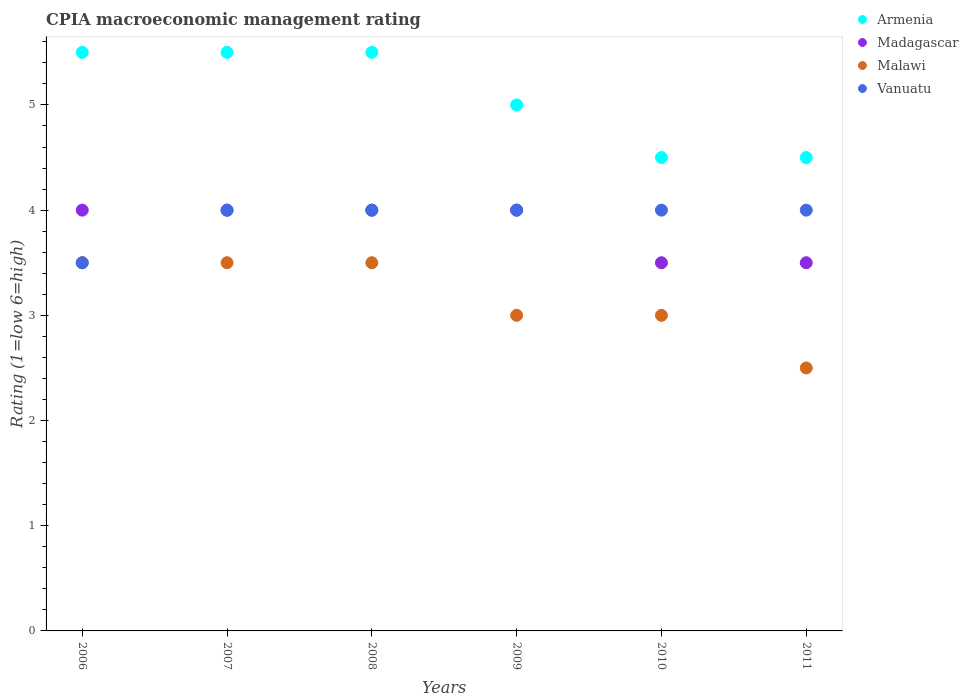How many different coloured dotlines are there?
Ensure brevity in your answer.  4. Is the number of dotlines equal to the number of legend labels?
Offer a very short reply. Yes. What is the CPIA rating in Madagascar in 2009?
Give a very brief answer. 4. Across all years, what is the minimum CPIA rating in Malawi?
Your answer should be very brief. 2.5. In which year was the CPIA rating in Malawi maximum?
Give a very brief answer. 2006. What is the total CPIA rating in Armenia in the graph?
Your answer should be compact. 30.5. What is the average CPIA rating in Madagascar per year?
Your answer should be compact. 3.83. In the year 2010, what is the difference between the CPIA rating in Vanuatu and CPIA rating in Madagascar?
Offer a terse response. 0.5. Is the CPIA rating in Madagascar in 2006 less than that in 2009?
Ensure brevity in your answer.  No. What is the difference between the highest and the second highest CPIA rating in Madagascar?
Give a very brief answer. 0. What is the difference between the highest and the lowest CPIA rating in Vanuatu?
Offer a terse response. 0.5. In how many years, is the CPIA rating in Malawi greater than the average CPIA rating in Malawi taken over all years?
Provide a short and direct response. 3. Is it the case that in every year, the sum of the CPIA rating in Madagascar and CPIA rating in Armenia  is greater than the sum of CPIA rating in Malawi and CPIA rating in Vanuatu?
Make the answer very short. No. Is it the case that in every year, the sum of the CPIA rating in Vanuatu and CPIA rating in Madagascar  is greater than the CPIA rating in Malawi?
Ensure brevity in your answer.  Yes. Does the CPIA rating in Malawi monotonically increase over the years?
Offer a very short reply. No. How many dotlines are there?
Offer a terse response. 4. What is the difference between two consecutive major ticks on the Y-axis?
Offer a very short reply. 1. Does the graph contain any zero values?
Your answer should be compact. No. Does the graph contain grids?
Offer a terse response. No. What is the title of the graph?
Provide a short and direct response. CPIA macroeconomic management rating. What is the label or title of the X-axis?
Ensure brevity in your answer.  Years. What is the label or title of the Y-axis?
Provide a succinct answer. Rating (1=low 6=high). What is the Rating (1=low 6=high) in Armenia in 2006?
Offer a very short reply. 5.5. What is the Rating (1=low 6=high) of Vanuatu in 2006?
Offer a very short reply. 3.5. What is the Rating (1=low 6=high) in Malawi in 2007?
Offer a very short reply. 3.5. What is the Rating (1=low 6=high) of Armenia in 2008?
Your answer should be very brief. 5.5. What is the Rating (1=low 6=high) in Madagascar in 2008?
Your answer should be very brief. 4. What is the Rating (1=low 6=high) in Malawi in 2008?
Make the answer very short. 3.5. What is the Rating (1=low 6=high) in Armenia in 2009?
Offer a terse response. 5. What is the Rating (1=low 6=high) of Malawi in 2009?
Provide a short and direct response. 3. What is the Rating (1=low 6=high) of Vanuatu in 2009?
Your answer should be very brief. 4. What is the Rating (1=low 6=high) of Armenia in 2010?
Give a very brief answer. 4.5. What is the Rating (1=low 6=high) in Madagascar in 2010?
Keep it short and to the point. 3.5. What is the Rating (1=low 6=high) of Vanuatu in 2010?
Give a very brief answer. 4. What is the Rating (1=low 6=high) of Madagascar in 2011?
Your answer should be very brief. 3.5. Across all years, what is the maximum Rating (1=low 6=high) of Vanuatu?
Provide a short and direct response. 4. Across all years, what is the minimum Rating (1=low 6=high) of Malawi?
Keep it short and to the point. 2.5. Across all years, what is the minimum Rating (1=low 6=high) in Vanuatu?
Your answer should be compact. 3.5. What is the total Rating (1=low 6=high) in Armenia in the graph?
Provide a succinct answer. 30.5. What is the total Rating (1=low 6=high) of Madagascar in the graph?
Your response must be concise. 23. What is the total Rating (1=low 6=high) in Malawi in the graph?
Provide a short and direct response. 19. What is the difference between the Rating (1=low 6=high) in Madagascar in 2006 and that in 2007?
Keep it short and to the point. 0. What is the difference between the Rating (1=low 6=high) of Malawi in 2006 and that in 2007?
Offer a terse response. 0. What is the difference between the Rating (1=low 6=high) of Vanuatu in 2006 and that in 2007?
Your answer should be very brief. -0.5. What is the difference between the Rating (1=low 6=high) in Madagascar in 2006 and that in 2008?
Keep it short and to the point. 0. What is the difference between the Rating (1=low 6=high) of Malawi in 2006 and that in 2008?
Make the answer very short. 0. What is the difference between the Rating (1=low 6=high) in Vanuatu in 2006 and that in 2008?
Offer a terse response. -0.5. What is the difference between the Rating (1=low 6=high) of Armenia in 2006 and that in 2010?
Provide a succinct answer. 1. What is the difference between the Rating (1=low 6=high) in Madagascar in 2006 and that in 2010?
Your answer should be very brief. 0.5. What is the difference between the Rating (1=low 6=high) in Malawi in 2006 and that in 2010?
Your answer should be very brief. 0.5. What is the difference between the Rating (1=low 6=high) in Malawi in 2006 and that in 2011?
Make the answer very short. 1. What is the difference between the Rating (1=low 6=high) of Vanuatu in 2007 and that in 2008?
Your response must be concise. 0. What is the difference between the Rating (1=low 6=high) in Armenia in 2007 and that in 2009?
Offer a terse response. 0.5. What is the difference between the Rating (1=low 6=high) of Madagascar in 2007 and that in 2009?
Offer a very short reply. 0. What is the difference between the Rating (1=low 6=high) in Malawi in 2007 and that in 2009?
Keep it short and to the point. 0.5. What is the difference between the Rating (1=low 6=high) in Vanuatu in 2007 and that in 2009?
Your answer should be very brief. 0. What is the difference between the Rating (1=low 6=high) in Malawi in 2007 and that in 2010?
Offer a terse response. 0.5. What is the difference between the Rating (1=low 6=high) of Armenia in 2007 and that in 2011?
Your answer should be compact. 1. What is the difference between the Rating (1=low 6=high) in Malawi in 2007 and that in 2011?
Your answer should be very brief. 1. What is the difference between the Rating (1=low 6=high) of Armenia in 2008 and that in 2009?
Provide a succinct answer. 0.5. What is the difference between the Rating (1=low 6=high) of Malawi in 2008 and that in 2009?
Your answer should be compact. 0.5. What is the difference between the Rating (1=low 6=high) of Armenia in 2008 and that in 2010?
Make the answer very short. 1. What is the difference between the Rating (1=low 6=high) of Madagascar in 2008 and that in 2010?
Give a very brief answer. 0.5. What is the difference between the Rating (1=low 6=high) in Malawi in 2008 and that in 2010?
Offer a terse response. 0.5. What is the difference between the Rating (1=low 6=high) of Armenia in 2008 and that in 2011?
Provide a short and direct response. 1. What is the difference between the Rating (1=low 6=high) of Armenia in 2009 and that in 2010?
Provide a succinct answer. 0.5. What is the difference between the Rating (1=low 6=high) in Vanuatu in 2009 and that in 2010?
Provide a succinct answer. 0. What is the difference between the Rating (1=low 6=high) of Vanuatu in 2009 and that in 2011?
Your response must be concise. 0. What is the difference between the Rating (1=low 6=high) of Armenia in 2010 and that in 2011?
Keep it short and to the point. 0. What is the difference between the Rating (1=low 6=high) in Vanuatu in 2010 and that in 2011?
Your answer should be compact. 0. What is the difference between the Rating (1=low 6=high) of Armenia in 2006 and the Rating (1=low 6=high) of Madagascar in 2007?
Offer a terse response. 1.5. What is the difference between the Rating (1=low 6=high) in Armenia in 2006 and the Rating (1=low 6=high) in Malawi in 2007?
Provide a short and direct response. 2. What is the difference between the Rating (1=low 6=high) of Armenia in 2006 and the Rating (1=low 6=high) of Vanuatu in 2007?
Offer a terse response. 1.5. What is the difference between the Rating (1=low 6=high) of Madagascar in 2006 and the Rating (1=low 6=high) of Malawi in 2007?
Your response must be concise. 0.5. What is the difference between the Rating (1=low 6=high) in Armenia in 2006 and the Rating (1=low 6=high) in Malawi in 2009?
Offer a very short reply. 2.5. What is the difference between the Rating (1=low 6=high) in Malawi in 2006 and the Rating (1=low 6=high) in Vanuatu in 2009?
Your response must be concise. -0.5. What is the difference between the Rating (1=low 6=high) of Armenia in 2006 and the Rating (1=low 6=high) of Malawi in 2010?
Offer a very short reply. 2.5. What is the difference between the Rating (1=low 6=high) in Madagascar in 2006 and the Rating (1=low 6=high) in Malawi in 2010?
Your response must be concise. 1. What is the difference between the Rating (1=low 6=high) in Madagascar in 2006 and the Rating (1=low 6=high) in Vanuatu in 2010?
Make the answer very short. 0. What is the difference between the Rating (1=low 6=high) of Armenia in 2006 and the Rating (1=low 6=high) of Vanuatu in 2011?
Make the answer very short. 1.5. What is the difference between the Rating (1=low 6=high) of Madagascar in 2006 and the Rating (1=low 6=high) of Malawi in 2011?
Ensure brevity in your answer.  1.5. What is the difference between the Rating (1=low 6=high) of Madagascar in 2006 and the Rating (1=low 6=high) of Vanuatu in 2011?
Your answer should be compact. 0. What is the difference between the Rating (1=low 6=high) in Malawi in 2006 and the Rating (1=low 6=high) in Vanuatu in 2011?
Your response must be concise. -0.5. What is the difference between the Rating (1=low 6=high) of Armenia in 2007 and the Rating (1=low 6=high) of Vanuatu in 2008?
Make the answer very short. 1.5. What is the difference between the Rating (1=low 6=high) in Madagascar in 2007 and the Rating (1=low 6=high) in Malawi in 2008?
Provide a short and direct response. 0.5. What is the difference between the Rating (1=low 6=high) of Armenia in 2007 and the Rating (1=low 6=high) of Malawi in 2009?
Give a very brief answer. 2.5. What is the difference between the Rating (1=low 6=high) of Madagascar in 2007 and the Rating (1=low 6=high) of Malawi in 2009?
Keep it short and to the point. 1. What is the difference between the Rating (1=low 6=high) in Armenia in 2007 and the Rating (1=low 6=high) in Madagascar in 2010?
Make the answer very short. 2. What is the difference between the Rating (1=low 6=high) in Madagascar in 2007 and the Rating (1=low 6=high) in Vanuatu in 2010?
Make the answer very short. 0. What is the difference between the Rating (1=low 6=high) in Armenia in 2008 and the Rating (1=low 6=high) in Madagascar in 2009?
Offer a very short reply. 1.5. What is the difference between the Rating (1=low 6=high) in Armenia in 2008 and the Rating (1=low 6=high) in Vanuatu in 2009?
Your answer should be compact. 1.5. What is the difference between the Rating (1=low 6=high) of Madagascar in 2008 and the Rating (1=low 6=high) of Vanuatu in 2009?
Your response must be concise. 0. What is the difference between the Rating (1=low 6=high) of Armenia in 2008 and the Rating (1=low 6=high) of Madagascar in 2010?
Provide a short and direct response. 2. What is the difference between the Rating (1=low 6=high) in Armenia in 2008 and the Rating (1=low 6=high) in Malawi in 2010?
Your answer should be very brief. 2.5. What is the difference between the Rating (1=low 6=high) in Armenia in 2008 and the Rating (1=low 6=high) in Vanuatu in 2010?
Your response must be concise. 1.5. What is the difference between the Rating (1=low 6=high) of Madagascar in 2008 and the Rating (1=low 6=high) of Malawi in 2010?
Ensure brevity in your answer.  1. What is the difference between the Rating (1=low 6=high) of Madagascar in 2008 and the Rating (1=low 6=high) of Vanuatu in 2010?
Provide a short and direct response. 0. What is the difference between the Rating (1=low 6=high) in Armenia in 2008 and the Rating (1=low 6=high) in Madagascar in 2011?
Provide a succinct answer. 2. What is the difference between the Rating (1=low 6=high) of Armenia in 2008 and the Rating (1=low 6=high) of Malawi in 2011?
Give a very brief answer. 3. What is the difference between the Rating (1=low 6=high) in Madagascar in 2008 and the Rating (1=low 6=high) in Malawi in 2011?
Your answer should be compact. 1.5. What is the difference between the Rating (1=low 6=high) in Madagascar in 2008 and the Rating (1=low 6=high) in Vanuatu in 2011?
Make the answer very short. 0. What is the difference between the Rating (1=low 6=high) in Malawi in 2008 and the Rating (1=low 6=high) in Vanuatu in 2011?
Your response must be concise. -0.5. What is the difference between the Rating (1=low 6=high) of Armenia in 2009 and the Rating (1=low 6=high) of Madagascar in 2010?
Keep it short and to the point. 1.5. What is the difference between the Rating (1=low 6=high) of Armenia in 2009 and the Rating (1=low 6=high) of Vanuatu in 2010?
Provide a succinct answer. 1. What is the difference between the Rating (1=low 6=high) in Madagascar in 2009 and the Rating (1=low 6=high) in Vanuatu in 2010?
Provide a succinct answer. 0. What is the difference between the Rating (1=low 6=high) in Armenia in 2009 and the Rating (1=low 6=high) in Malawi in 2011?
Offer a terse response. 2.5. What is the difference between the Rating (1=low 6=high) in Madagascar in 2009 and the Rating (1=low 6=high) in Malawi in 2011?
Keep it short and to the point. 1.5. What is the difference between the Rating (1=low 6=high) in Malawi in 2009 and the Rating (1=low 6=high) in Vanuatu in 2011?
Provide a succinct answer. -1. What is the difference between the Rating (1=low 6=high) of Armenia in 2010 and the Rating (1=low 6=high) of Vanuatu in 2011?
Offer a terse response. 0.5. What is the difference between the Rating (1=low 6=high) of Madagascar in 2010 and the Rating (1=low 6=high) of Malawi in 2011?
Give a very brief answer. 1. What is the difference between the Rating (1=low 6=high) of Madagascar in 2010 and the Rating (1=low 6=high) of Vanuatu in 2011?
Keep it short and to the point. -0.5. What is the difference between the Rating (1=low 6=high) of Malawi in 2010 and the Rating (1=low 6=high) of Vanuatu in 2011?
Ensure brevity in your answer.  -1. What is the average Rating (1=low 6=high) in Armenia per year?
Your response must be concise. 5.08. What is the average Rating (1=low 6=high) of Madagascar per year?
Ensure brevity in your answer.  3.83. What is the average Rating (1=low 6=high) in Malawi per year?
Your answer should be compact. 3.17. What is the average Rating (1=low 6=high) in Vanuatu per year?
Offer a terse response. 3.92. In the year 2006, what is the difference between the Rating (1=low 6=high) of Armenia and Rating (1=low 6=high) of Madagascar?
Offer a very short reply. 1.5. In the year 2006, what is the difference between the Rating (1=low 6=high) in Armenia and Rating (1=low 6=high) in Malawi?
Offer a very short reply. 2. In the year 2006, what is the difference between the Rating (1=low 6=high) in Malawi and Rating (1=low 6=high) in Vanuatu?
Make the answer very short. 0. In the year 2007, what is the difference between the Rating (1=low 6=high) in Armenia and Rating (1=low 6=high) in Madagascar?
Make the answer very short. 1.5. In the year 2007, what is the difference between the Rating (1=low 6=high) in Armenia and Rating (1=low 6=high) in Malawi?
Your response must be concise. 2. In the year 2007, what is the difference between the Rating (1=low 6=high) in Armenia and Rating (1=low 6=high) in Vanuatu?
Provide a succinct answer. 1.5. In the year 2008, what is the difference between the Rating (1=low 6=high) of Armenia and Rating (1=low 6=high) of Madagascar?
Provide a short and direct response. 1.5. In the year 2008, what is the difference between the Rating (1=low 6=high) of Armenia and Rating (1=low 6=high) of Malawi?
Your response must be concise. 2. In the year 2008, what is the difference between the Rating (1=low 6=high) of Armenia and Rating (1=low 6=high) of Vanuatu?
Offer a terse response. 1.5. In the year 2008, what is the difference between the Rating (1=low 6=high) of Madagascar and Rating (1=low 6=high) of Vanuatu?
Ensure brevity in your answer.  0. In the year 2008, what is the difference between the Rating (1=low 6=high) in Malawi and Rating (1=low 6=high) in Vanuatu?
Provide a succinct answer. -0.5. In the year 2009, what is the difference between the Rating (1=low 6=high) in Armenia and Rating (1=low 6=high) in Malawi?
Provide a succinct answer. 2. In the year 2009, what is the difference between the Rating (1=low 6=high) of Madagascar and Rating (1=low 6=high) of Vanuatu?
Provide a short and direct response. 0. In the year 2010, what is the difference between the Rating (1=low 6=high) of Armenia and Rating (1=low 6=high) of Madagascar?
Provide a succinct answer. 1. In the year 2010, what is the difference between the Rating (1=low 6=high) in Armenia and Rating (1=low 6=high) in Malawi?
Your response must be concise. 1.5. In the year 2011, what is the difference between the Rating (1=low 6=high) of Armenia and Rating (1=low 6=high) of Vanuatu?
Keep it short and to the point. 0.5. In the year 2011, what is the difference between the Rating (1=low 6=high) in Malawi and Rating (1=low 6=high) in Vanuatu?
Your answer should be very brief. -1.5. What is the ratio of the Rating (1=low 6=high) in Armenia in 2006 to that in 2007?
Offer a very short reply. 1. What is the ratio of the Rating (1=low 6=high) of Armenia in 2006 to that in 2008?
Give a very brief answer. 1. What is the ratio of the Rating (1=low 6=high) of Madagascar in 2006 to that in 2008?
Your answer should be very brief. 1. What is the ratio of the Rating (1=low 6=high) in Vanuatu in 2006 to that in 2008?
Make the answer very short. 0.88. What is the ratio of the Rating (1=low 6=high) in Madagascar in 2006 to that in 2009?
Your answer should be very brief. 1. What is the ratio of the Rating (1=low 6=high) in Vanuatu in 2006 to that in 2009?
Offer a terse response. 0.88. What is the ratio of the Rating (1=low 6=high) in Armenia in 2006 to that in 2010?
Make the answer very short. 1.22. What is the ratio of the Rating (1=low 6=high) of Madagascar in 2006 to that in 2010?
Provide a short and direct response. 1.14. What is the ratio of the Rating (1=low 6=high) in Malawi in 2006 to that in 2010?
Offer a terse response. 1.17. What is the ratio of the Rating (1=low 6=high) in Armenia in 2006 to that in 2011?
Your answer should be compact. 1.22. What is the ratio of the Rating (1=low 6=high) of Malawi in 2006 to that in 2011?
Ensure brevity in your answer.  1.4. What is the ratio of the Rating (1=low 6=high) in Armenia in 2007 to that in 2008?
Ensure brevity in your answer.  1. What is the ratio of the Rating (1=low 6=high) in Madagascar in 2007 to that in 2008?
Provide a succinct answer. 1. What is the ratio of the Rating (1=low 6=high) of Vanuatu in 2007 to that in 2008?
Ensure brevity in your answer.  1. What is the ratio of the Rating (1=low 6=high) in Malawi in 2007 to that in 2009?
Your response must be concise. 1.17. What is the ratio of the Rating (1=low 6=high) of Vanuatu in 2007 to that in 2009?
Offer a very short reply. 1. What is the ratio of the Rating (1=low 6=high) of Armenia in 2007 to that in 2010?
Provide a succinct answer. 1.22. What is the ratio of the Rating (1=low 6=high) of Vanuatu in 2007 to that in 2010?
Your answer should be compact. 1. What is the ratio of the Rating (1=low 6=high) of Armenia in 2007 to that in 2011?
Give a very brief answer. 1.22. What is the ratio of the Rating (1=low 6=high) of Madagascar in 2007 to that in 2011?
Provide a succinct answer. 1.14. What is the ratio of the Rating (1=low 6=high) of Malawi in 2007 to that in 2011?
Offer a very short reply. 1.4. What is the ratio of the Rating (1=low 6=high) of Madagascar in 2008 to that in 2009?
Your answer should be very brief. 1. What is the ratio of the Rating (1=low 6=high) in Vanuatu in 2008 to that in 2009?
Make the answer very short. 1. What is the ratio of the Rating (1=low 6=high) in Armenia in 2008 to that in 2010?
Make the answer very short. 1.22. What is the ratio of the Rating (1=low 6=high) in Armenia in 2008 to that in 2011?
Keep it short and to the point. 1.22. What is the ratio of the Rating (1=low 6=high) of Vanuatu in 2008 to that in 2011?
Offer a very short reply. 1. What is the ratio of the Rating (1=low 6=high) of Vanuatu in 2009 to that in 2010?
Provide a succinct answer. 1. What is the ratio of the Rating (1=low 6=high) of Armenia in 2009 to that in 2011?
Your answer should be very brief. 1.11. What is the ratio of the Rating (1=low 6=high) in Vanuatu in 2009 to that in 2011?
Give a very brief answer. 1. What is the ratio of the Rating (1=low 6=high) of Madagascar in 2010 to that in 2011?
Offer a terse response. 1. What is the ratio of the Rating (1=low 6=high) of Vanuatu in 2010 to that in 2011?
Make the answer very short. 1. What is the difference between the highest and the second highest Rating (1=low 6=high) in Malawi?
Provide a succinct answer. 0. What is the difference between the highest and the second highest Rating (1=low 6=high) in Vanuatu?
Your response must be concise. 0. What is the difference between the highest and the lowest Rating (1=low 6=high) of Vanuatu?
Make the answer very short. 0.5. 